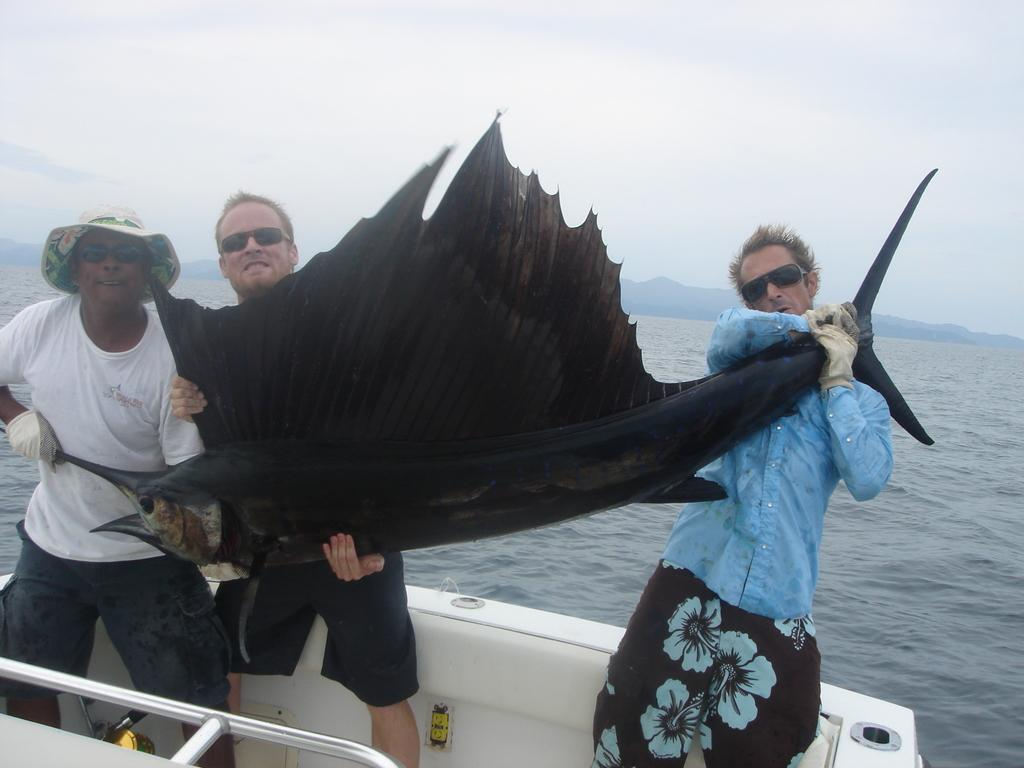How many people are in the image? There are three men in the image. What are the men doing in the image? The men are standing on a boat and holding a fish. What can be seen below the boat in the image? There is water visible in the image. What is visible in the background of the image? There are mountains in the background. What is visible at the top of the image? The sky is visible at the top of the image. What type of hammer is being used by one of the men in the image? There is no hammer present in the image; the men are holding a fish. What drink is being consumed by the men in the image? There is no drink visible in the image; the men are holding a fish. 